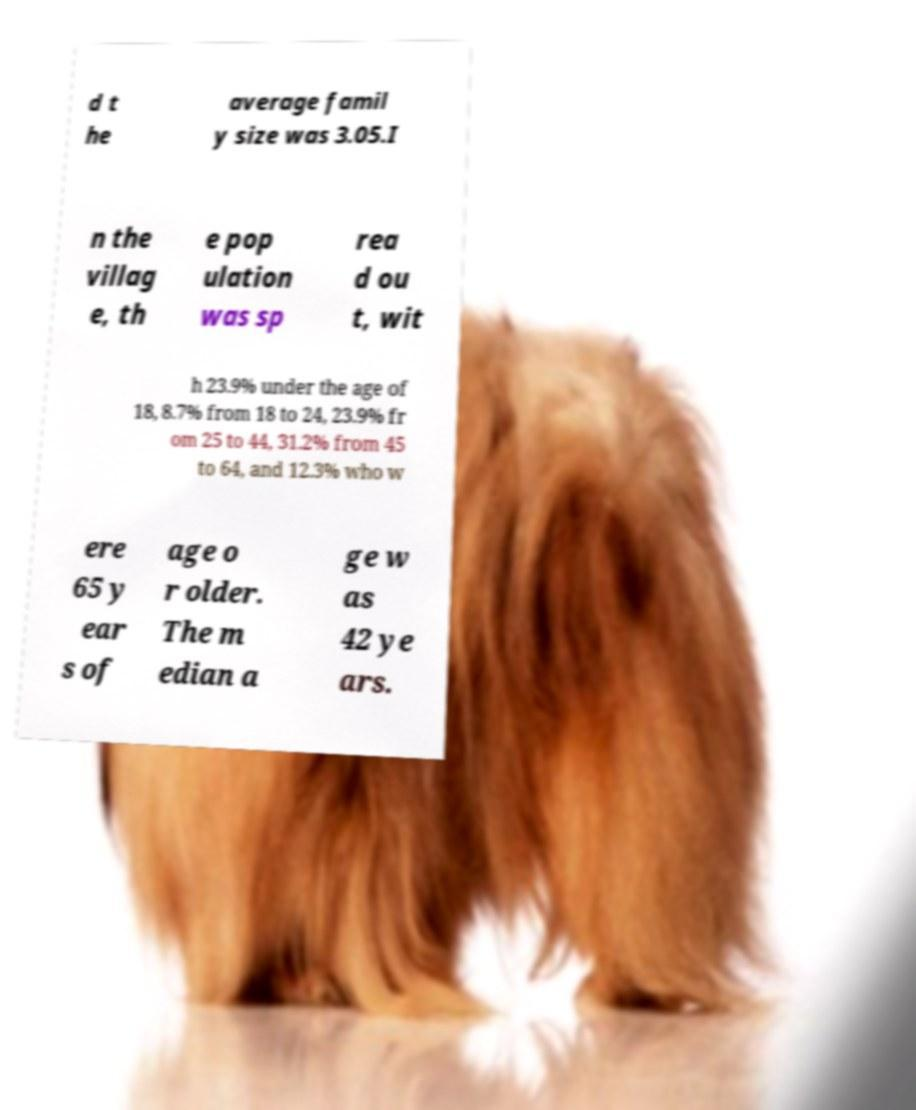What messages or text are displayed in this image? I need them in a readable, typed format. d t he average famil y size was 3.05.I n the villag e, th e pop ulation was sp rea d ou t, wit h 23.9% under the age of 18, 8.7% from 18 to 24, 23.9% fr om 25 to 44, 31.2% from 45 to 64, and 12.3% who w ere 65 y ear s of age o r older. The m edian a ge w as 42 ye ars. 